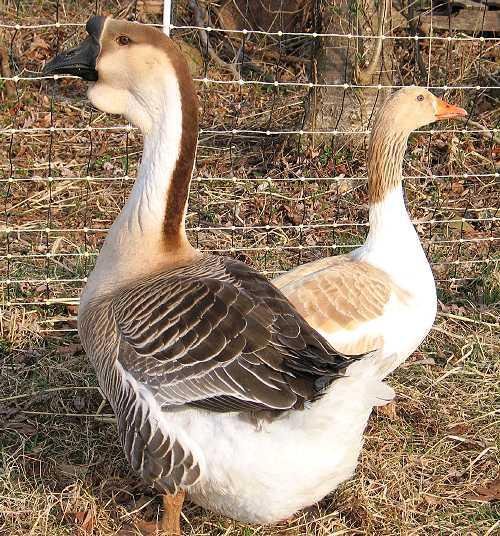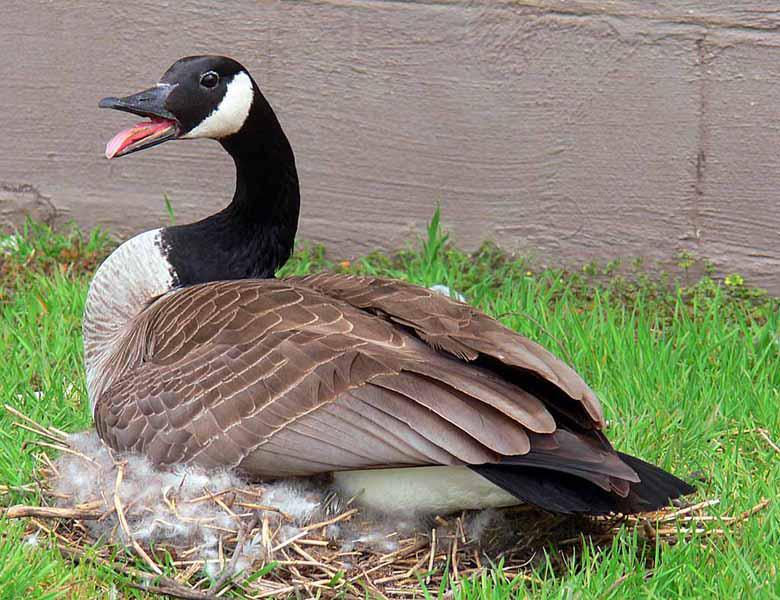The first image is the image on the left, the second image is the image on the right. For the images displayed, is the sentence "There are two geese with their beaks pressed together in one of the images." factually correct? Answer yes or no. No. The first image is the image on the left, the second image is the image on the right. For the images displayed, is the sentence "geese are facing each other and touching beaks" factually correct? Answer yes or no. No. 